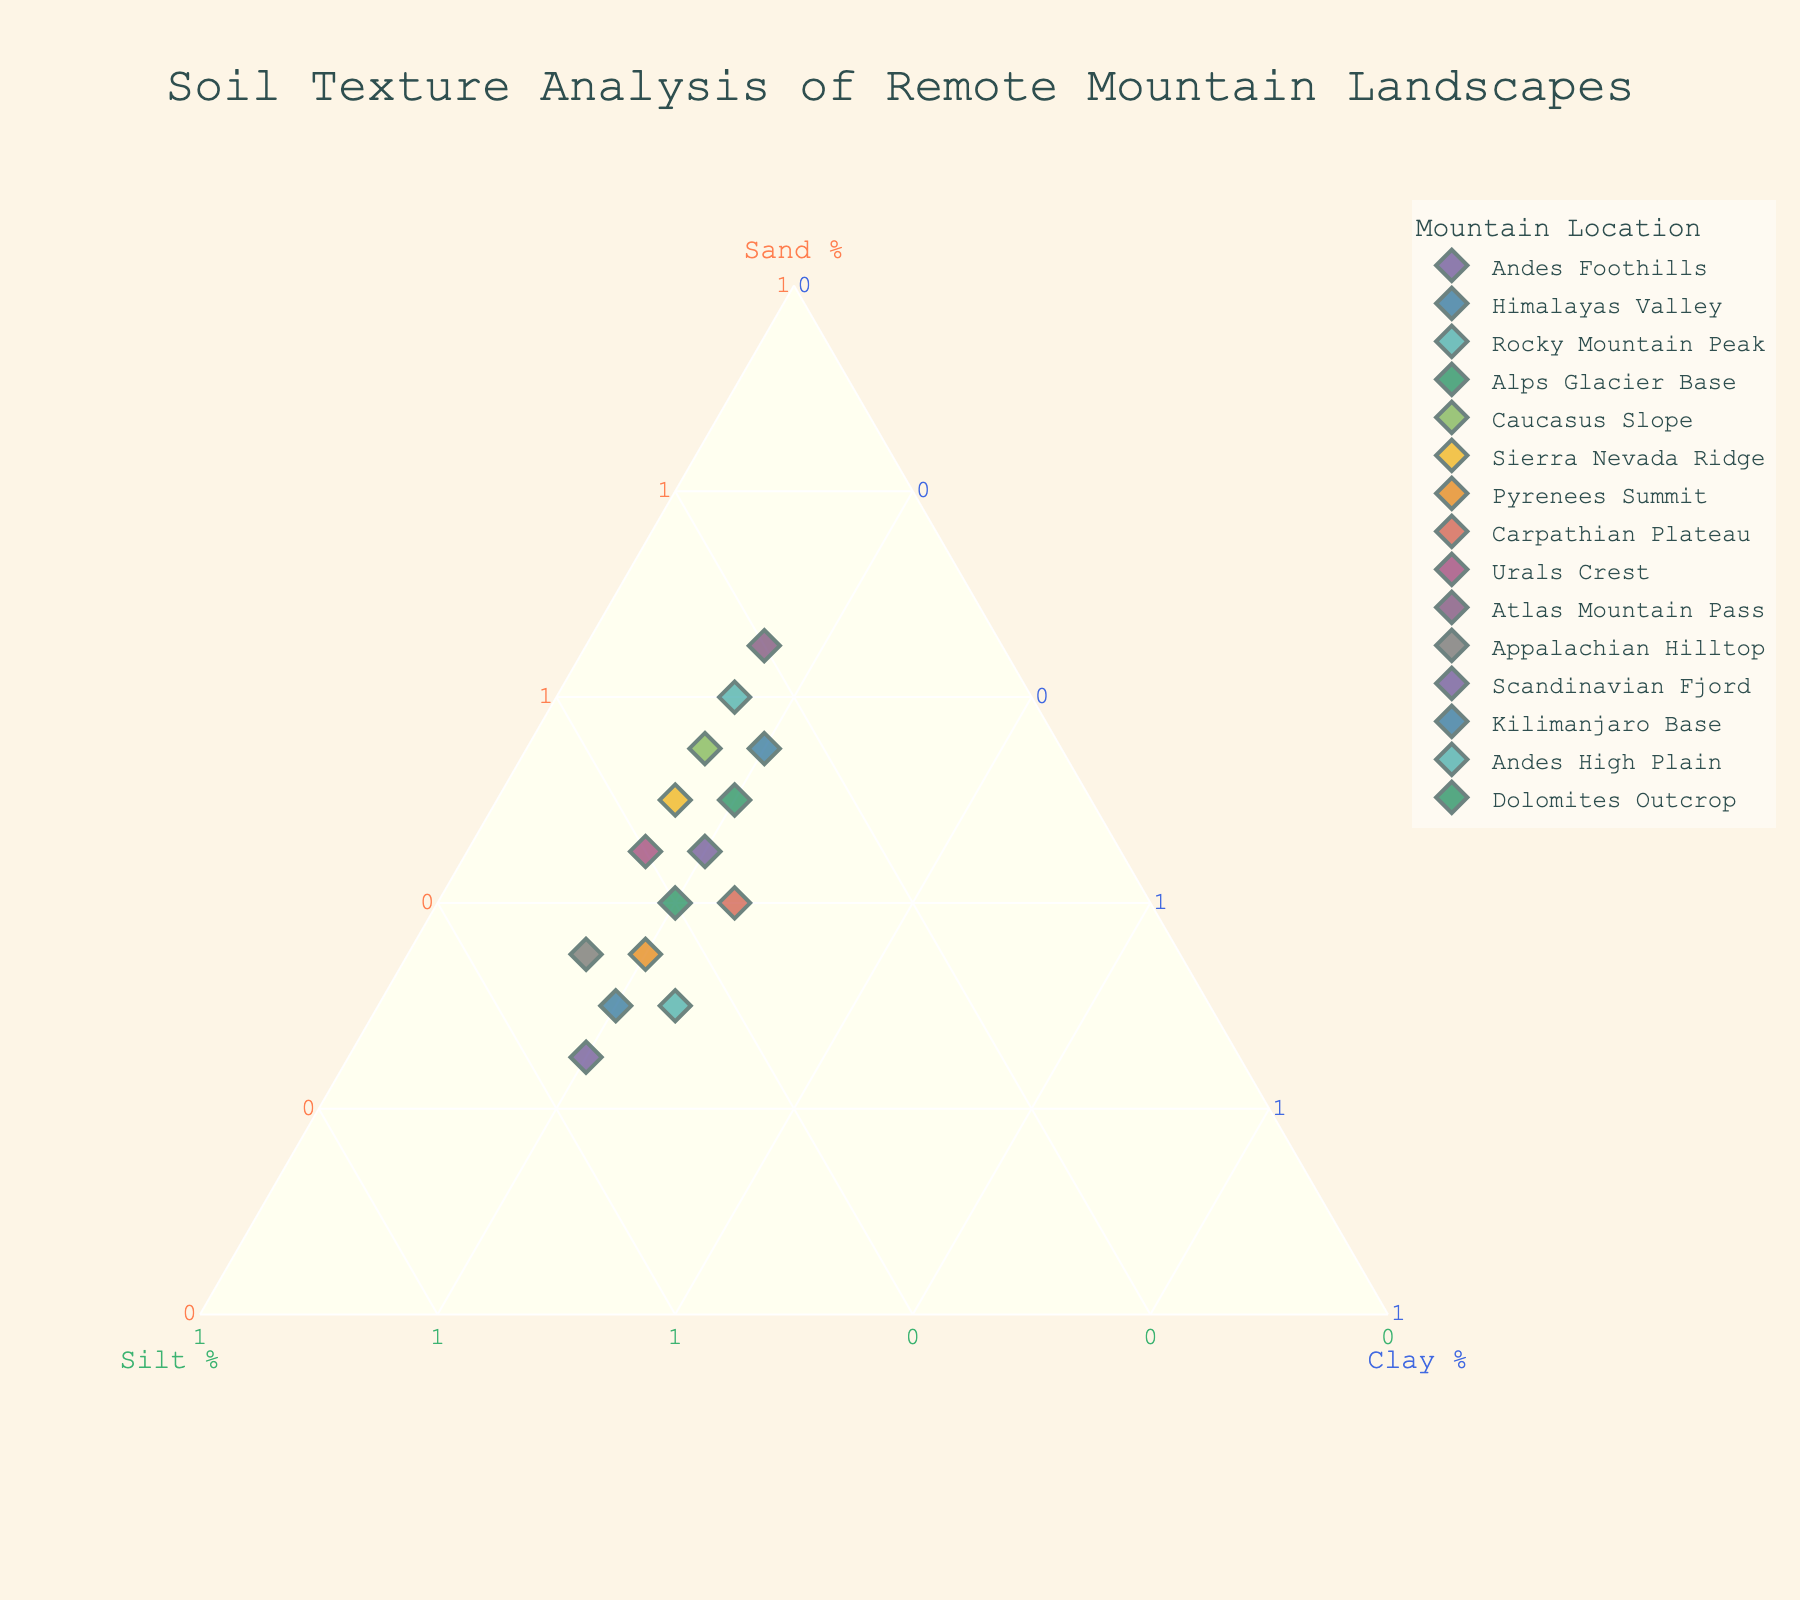Which location has the highest sand percentage? By looking at the plot, find the location with the highest value along the sand axis.
Answer: Atlas Mountain Pass What is the title of the figure? Check the top of the figure where the title is usually located.
Answer: Soil Texture Analysis of Remote Mountain Landscapes Which location has equal percentages of sand and silt? Find a point on the plot where the sand and silt percentages are equal.
Answer: Alps Glacier Base How many locations have a clay percentage of 20%? Count all the data points on the plot that have a clay percentage of 20%.
Answer: 8 Compare the silt percentage in the Pyrenees Summit and the Appalachian Hilltop. Which one is higher? Look at the data points for Pyrenees Summit and Appalachian Hilltop, then compare their positions along the silt axis.
Answer: Pyrenees Summit If you average the sand percentage of the Andes Foothills and the Caucasus Slope, what do you get? Andes Foothills has 45% sand and Caucasus Slope has 55% sand. Average = (45 + 55) / 2 = 50%.
Answer: 50% Which location has the smallest clay percentage? Find the location with the lowest value along the clay axis.
Answer: Rocky Mountain Peak What is the percentage range of silt for all locations? Identify the highest and lowest silt percentages on the plot and subtract the lowest from the highest. The range is 55% (highest) - 20% (lowest).
Answer: 35% Which location has a sand percentage closest to 50%? Look for the data point with a sand percentage nearest to 50% on the plot.
Answer: Sierra Nevada Ridge Determine if the total of sand, silt, and clay for the Urals Crest equals 100%. For Urals Crest, verify Sand (45%), Silt (40%), and Clay (15%) sum up: 45 + 40 + 15 = 100%.
Answer: Yes 